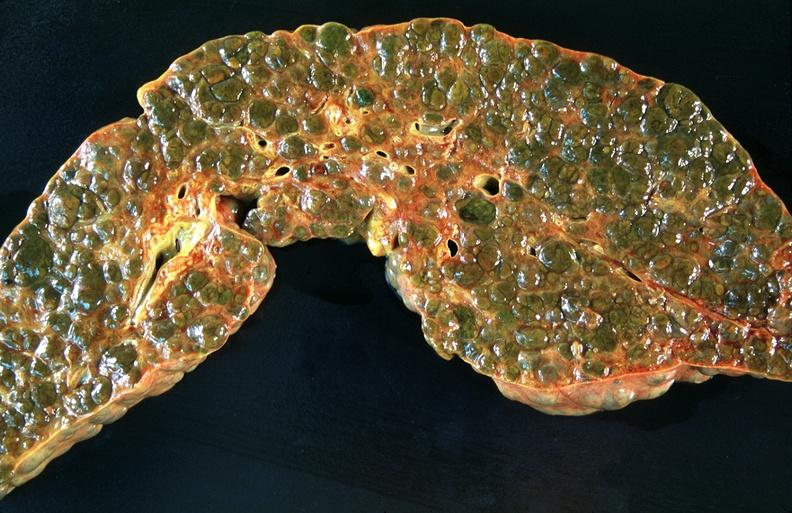s hepatobiliary present?
Answer the question using a single word or phrase. Yes 